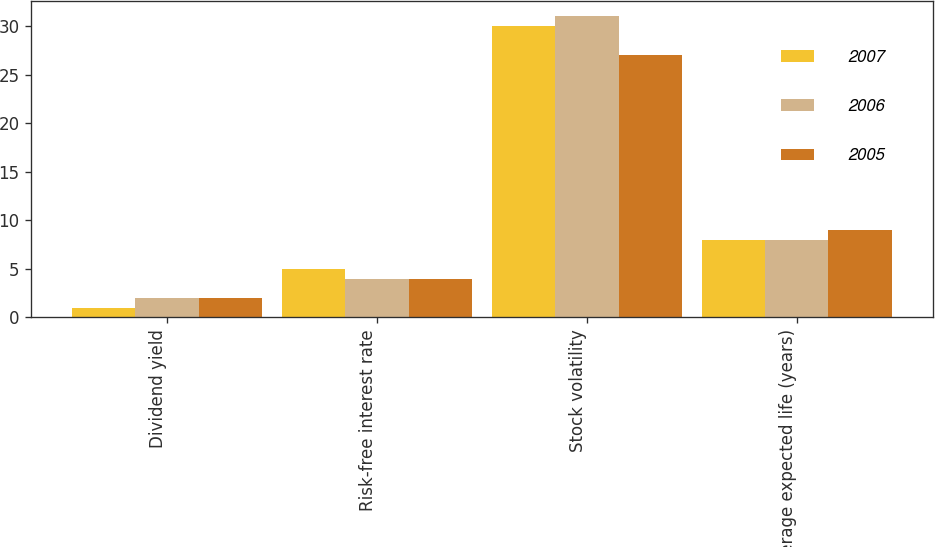Convert chart. <chart><loc_0><loc_0><loc_500><loc_500><stacked_bar_chart><ecel><fcel>Dividend yield<fcel>Risk-free interest rate<fcel>Stock volatility<fcel>Average expected life (years)<nl><fcel>2007<fcel>1<fcel>5<fcel>30<fcel>8<nl><fcel>2006<fcel>2<fcel>4<fcel>31<fcel>8<nl><fcel>2005<fcel>2<fcel>4<fcel>27<fcel>9<nl></chart> 